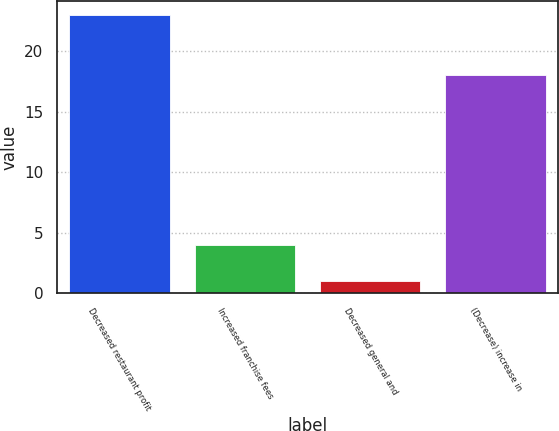Convert chart. <chart><loc_0><loc_0><loc_500><loc_500><bar_chart><fcel>Decreased restaurant profit<fcel>Increased franchise fees<fcel>Decreased general and<fcel>(Decrease) increase in<nl><fcel>23<fcel>4<fcel>1<fcel>18<nl></chart> 